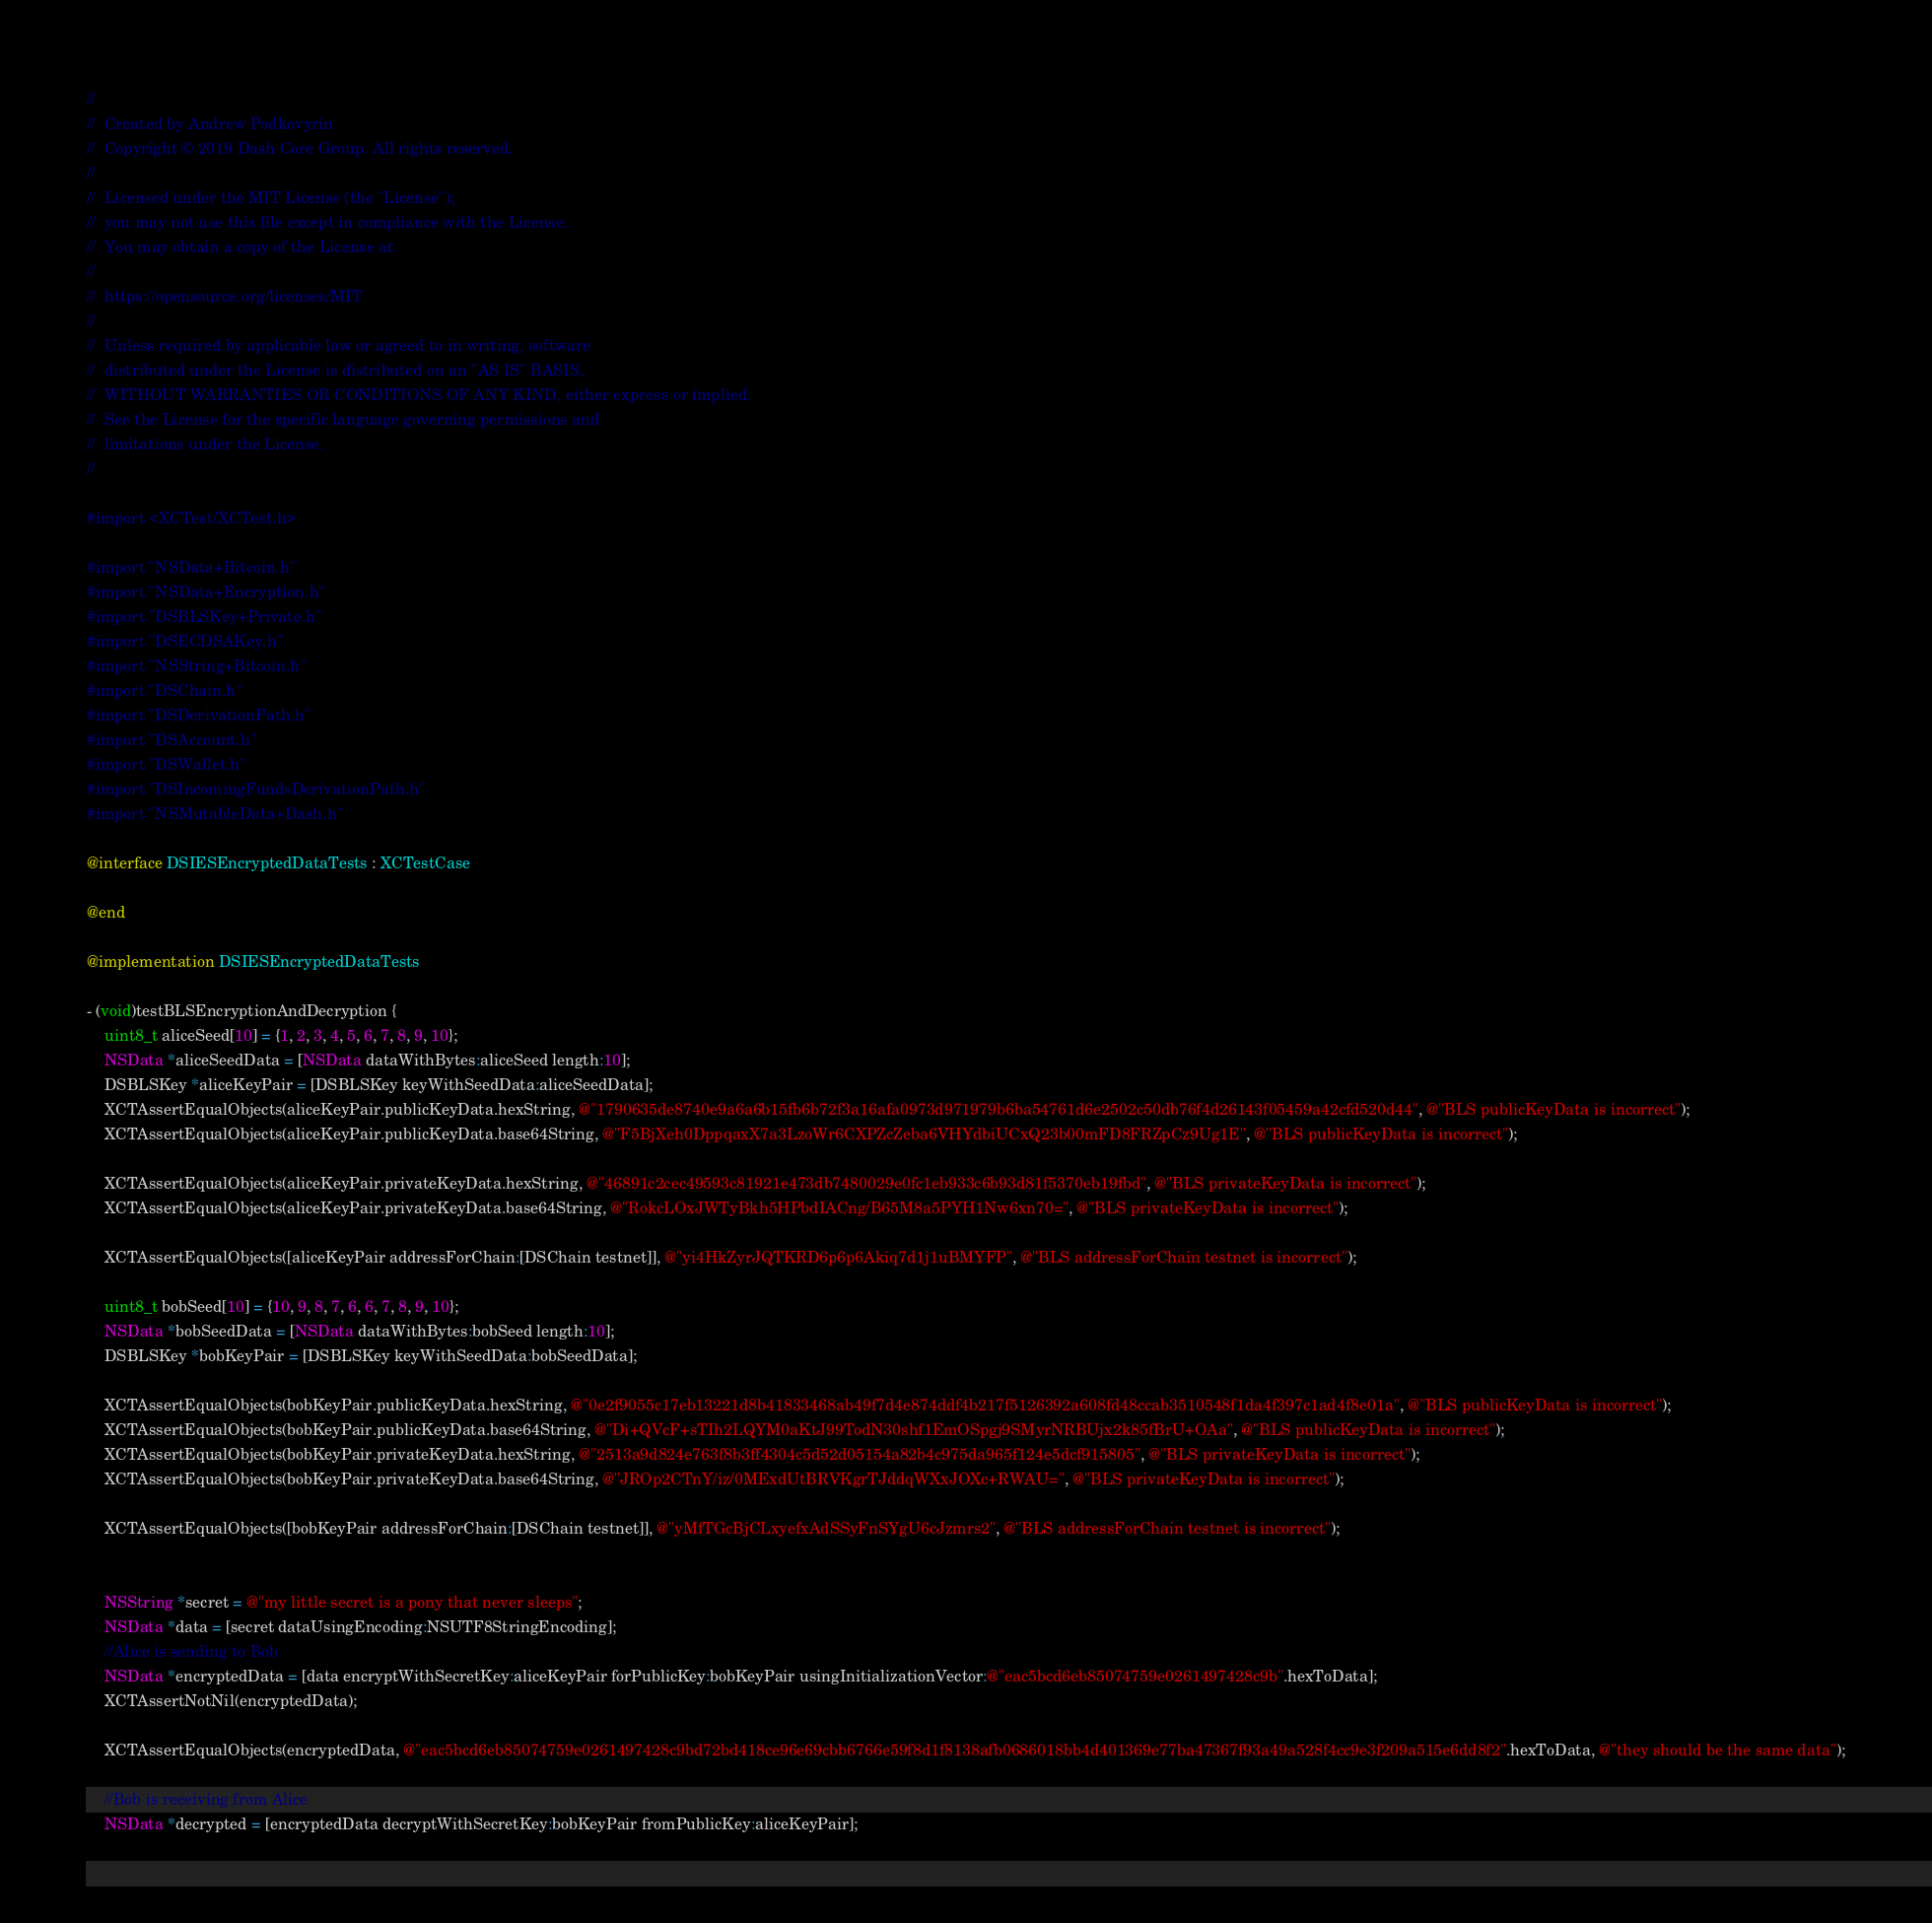<code> <loc_0><loc_0><loc_500><loc_500><_ObjectiveC_>//  
//  Created by Andrew Podkovyrin
//  Copyright © 2019 Dash Core Group. All rights reserved.
//
//  Licensed under the MIT License (the "License");
//  you may not use this file except in compliance with the License.
//  You may obtain a copy of the License at
//
//  https://opensource.org/licenses/MIT
//
//  Unless required by applicable law or agreed to in writing, software
//  distributed under the License is distributed on an "AS IS" BASIS,
//  WITHOUT WARRANTIES OR CONDITIONS OF ANY KIND, either express or implied.
//  See the License for the specific language governing permissions and
//  limitations under the License.
//

#import <XCTest/XCTest.h>

#import "NSData+Bitcoin.h"
#import "NSData+Encryption.h"
#import "DSBLSKey+Private.h"
#import "DSECDSAKey.h"
#import "NSString+Bitcoin.h"
#import "DSChain.h"
#import "DSDerivationPath.h"
#import "DSAccount.h"
#import "DSWallet.h"
#import "DSIncomingFundsDerivationPath.h"
#import "NSMutableData+Dash.h"

@interface DSIESEncryptedDataTests : XCTestCase

@end

@implementation DSIESEncryptedDataTests

- (void)testBLSEncryptionAndDecryption {
    uint8_t aliceSeed[10] = {1, 2, 3, 4, 5, 6, 7, 8, 9, 10};
    NSData *aliceSeedData = [NSData dataWithBytes:aliceSeed length:10];
    DSBLSKey *aliceKeyPair = [DSBLSKey keyWithSeedData:aliceSeedData];
    XCTAssertEqualObjects(aliceKeyPair.publicKeyData.hexString, @"1790635de8740e9a6a6b15fb6b72f3a16afa0973d971979b6ba54761d6e2502c50db76f4d26143f05459a42cfd520d44", @"BLS publicKeyData is incorrect");
    XCTAssertEqualObjects(aliceKeyPair.publicKeyData.base64String, @"F5BjXeh0DppqaxX7a3LzoWr6CXPZcZeba6VHYdbiUCxQ23b00mFD8FRZpCz9Ug1E", @"BLS publicKeyData is incorrect");
    
    XCTAssertEqualObjects(aliceKeyPair.privateKeyData.hexString, @"46891c2cec49593c81921e473db7480029e0fc1eb933c6b93d81f5370eb19fbd", @"BLS privateKeyData is incorrect");
    XCTAssertEqualObjects(aliceKeyPair.privateKeyData.base64String, @"RokcLOxJWTyBkh5HPbdIACng/B65M8a5PYH1Nw6xn70=", @"BLS privateKeyData is incorrect");
    
    XCTAssertEqualObjects([aliceKeyPair addressForChain:[DSChain testnet]], @"yi4HkZyrJQTKRD6p6p6Akiq7d1j1uBMYFP", @"BLS addressForChain testnet is incorrect");
    
    uint8_t bobSeed[10] = {10, 9, 8, 7, 6, 6, 7, 8, 9, 10};
    NSData *bobSeedData = [NSData dataWithBytes:bobSeed length:10];
    DSBLSKey *bobKeyPair = [DSBLSKey keyWithSeedData:bobSeedData];
    
    XCTAssertEqualObjects(bobKeyPair.publicKeyData.hexString, @"0e2f9055c17eb13221d8b41833468ab49f7d4e874ddf4b217f5126392a608fd48ccab3510548f1da4f397c1ad4f8e01a", @"BLS publicKeyData is incorrect");
    XCTAssertEqualObjects(bobKeyPair.publicKeyData.base64String, @"Di+QVcF+sTIh2LQYM0aKtJ99TodN30shf1EmOSpgj9SMyrNRBUjx2k85fBrU+OAa", @"BLS publicKeyData is incorrect");
    XCTAssertEqualObjects(bobKeyPair.privateKeyData.hexString, @"2513a9d824e763f8b3ff4304c5d52d05154a82b4c975da965f124e5dcf915805", @"BLS privateKeyData is incorrect");
    XCTAssertEqualObjects(bobKeyPair.privateKeyData.base64String, @"JROp2CTnY/iz/0MExdUtBRVKgrTJddqWXxJOXc+RWAU=", @"BLS privateKeyData is incorrect");
    
    XCTAssertEqualObjects([bobKeyPair addressForChain:[DSChain testnet]], @"yMfTGcBjCLxyefxAdSSyFnSYgU6cJzmrs2", @"BLS addressForChain testnet is incorrect");
    

    NSString *secret = @"my little secret is a pony that never sleeps";
    NSData *data = [secret dataUsingEncoding:NSUTF8StringEncoding];
    //Alice is sending to Bob
    NSData *encryptedData = [data encryptWithSecretKey:aliceKeyPair forPublicKey:bobKeyPair usingInitializationVector:@"eac5bcd6eb85074759e0261497428c9b".hexToData];
    XCTAssertNotNil(encryptedData);
    
    XCTAssertEqualObjects(encryptedData, @"eac5bcd6eb85074759e0261497428c9bd72bd418ce96e69cbb6766e59f8d1f8138afb0686018bb4d401369e77ba47367f93a49a528f4cc9e3f209a515e6dd8f2".hexToData, @"they should be the same data");
    
    //Bob is receiving from Alice
    NSData *decrypted = [encryptedData decryptWithSecretKey:bobKeyPair fromPublicKey:aliceKeyPair];</code> 